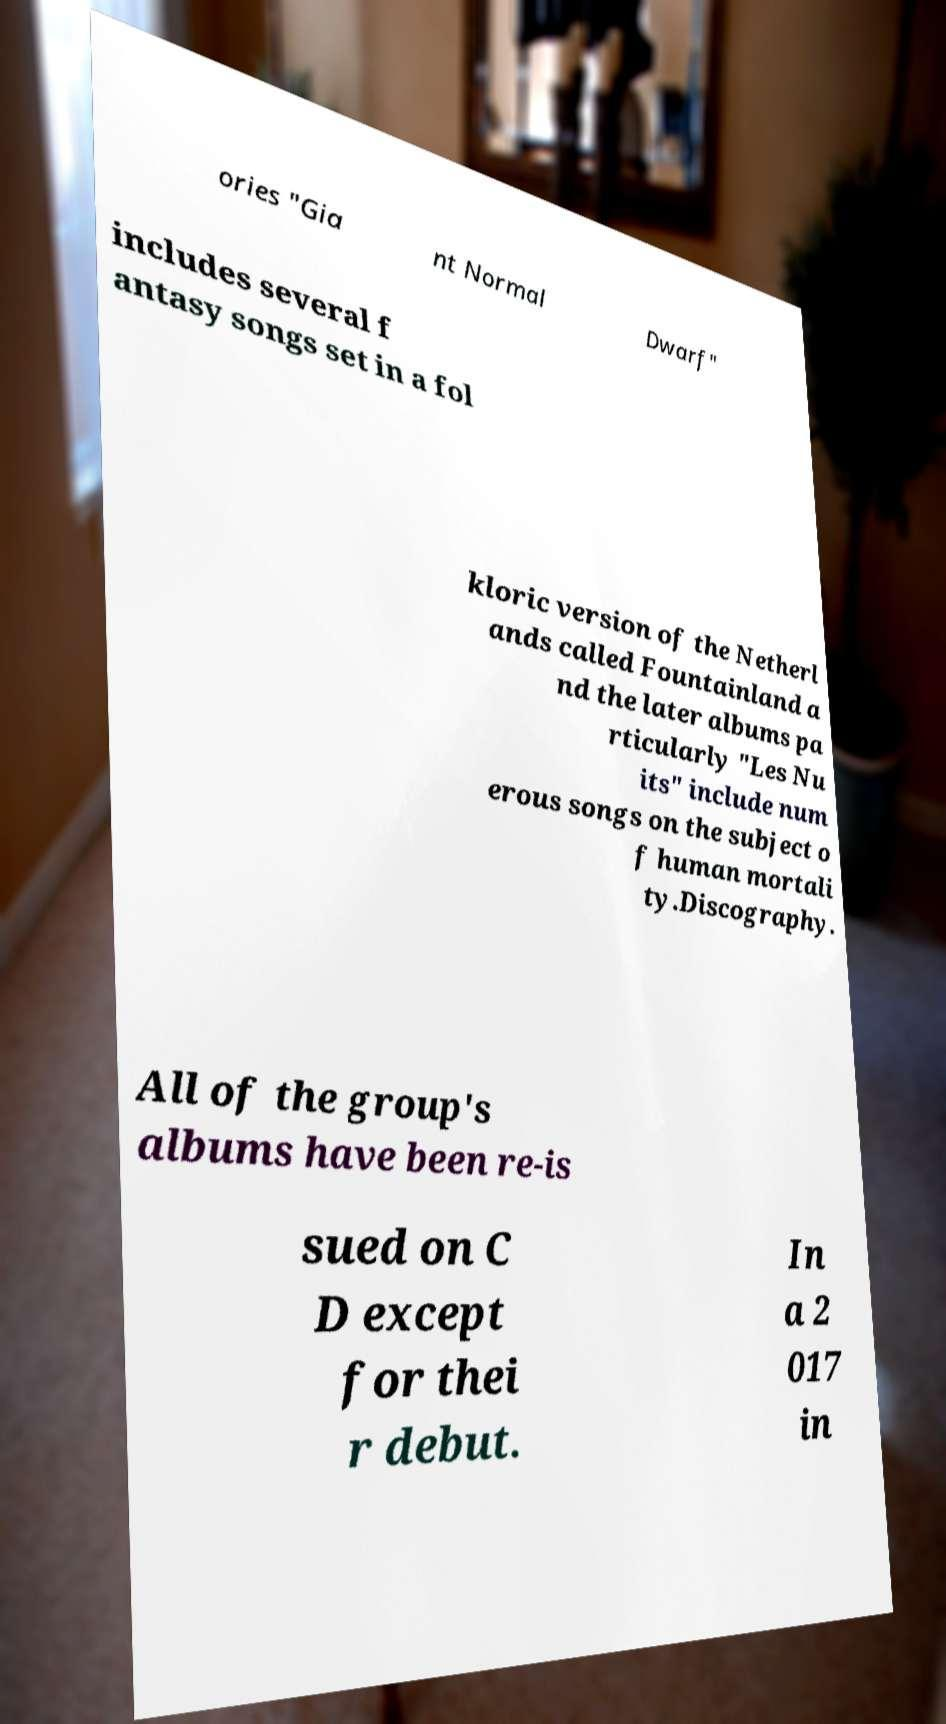I need the written content from this picture converted into text. Can you do that? ories "Gia nt Normal Dwarf" includes several f antasy songs set in a fol kloric version of the Netherl ands called Fountainland a nd the later albums pa rticularly "Les Nu its" include num erous songs on the subject o f human mortali ty.Discography. All of the group's albums have been re-is sued on C D except for thei r debut. In a 2 017 in 